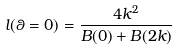<formula> <loc_0><loc_0><loc_500><loc_500>l ( \theta = 0 ) = \frac { 4 k ^ { 2 } } { B ( 0 ) + B ( 2 k ) }</formula> 